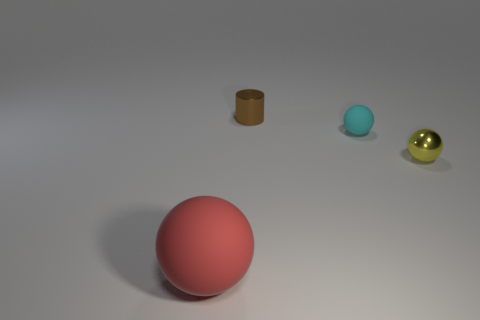Add 3 large red balls. How many objects exist? 7 Subtract all spheres. How many objects are left? 1 Subtract all large red matte objects. Subtract all spheres. How many objects are left? 0 Add 2 spheres. How many spheres are left? 5 Add 2 brown things. How many brown things exist? 3 Subtract 0 yellow blocks. How many objects are left? 4 